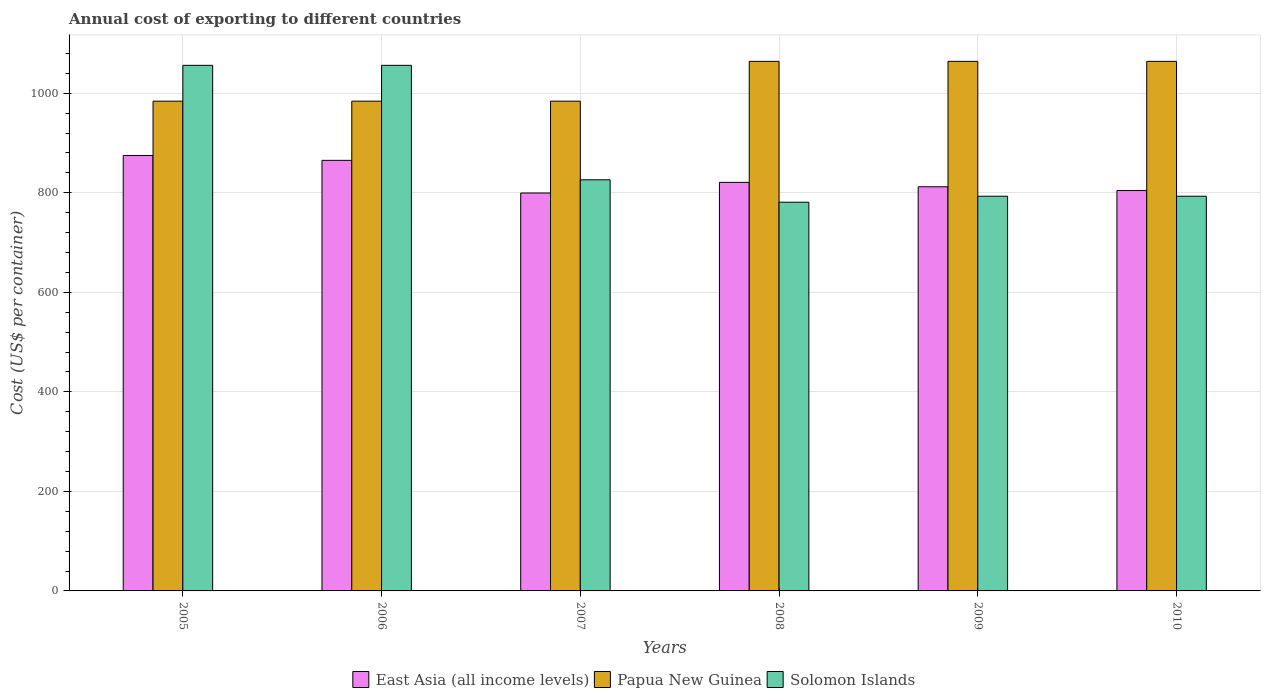How many different coloured bars are there?
Your response must be concise. 3. How many groups of bars are there?
Give a very brief answer. 6. Are the number of bars on each tick of the X-axis equal?
Your response must be concise. Yes. How many bars are there on the 2nd tick from the left?
Provide a short and direct response. 3. What is the total annual cost of exporting in Papua New Guinea in 2009?
Provide a succinct answer. 1064. Across all years, what is the maximum total annual cost of exporting in Papua New Guinea?
Offer a very short reply. 1064. Across all years, what is the minimum total annual cost of exporting in East Asia (all income levels)?
Keep it short and to the point. 799.5. In which year was the total annual cost of exporting in Solomon Islands minimum?
Ensure brevity in your answer.  2008. What is the total total annual cost of exporting in Solomon Islands in the graph?
Offer a very short reply. 5305. What is the difference between the total annual cost of exporting in East Asia (all income levels) in 2008 and the total annual cost of exporting in Solomon Islands in 2006?
Offer a very short reply. -235.14. What is the average total annual cost of exporting in East Asia (all income levels) per year?
Ensure brevity in your answer.  829.46. In the year 2009, what is the difference between the total annual cost of exporting in Papua New Guinea and total annual cost of exporting in East Asia (all income levels)?
Your answer should be compact. 252. In how many years, is the total annual cost of exporting in East Asia (all income levels) greater than 480 US$?
Your answer should be compact. 6. Is the total annual cost of exporting in Solomon Islands in 2005 less than that in 2007?
Make the answer very short. No. Is the difference between the total annual cost of exporting in Papua New Guinea in 2008 and 2010 greater than the difference between the total annual cost of exporting in East Asia (all income levels) in 2008 and 2010?
Offer a very short reply. No. What is the difference between the highest and the second highest total annual cost of exporting in East Asia (all income levels)?
Give a very brief answer. 9.78. What is the difference between the highest and the lowest total annual cost of exporting in East Asia (all income levels)?
Ensure brevity in your answer.  75.39. In how many years, is the total annual cost of exporting in Solomon Islands greater than the average total annual cost of exporting in Solomon Islands taken over all years?
Offer a very short reply. 2. Is the sum of the total annual cost of exporting in Solomon Islands in 2005 and 2010 greater than the maximum total annual cost of exporting in East Asia (all income levels) across all years?
Give a very brief answer. Yes. What does the 1st bar from the left in 2006 represents?
Your answer should be very brief. East Asia (all income levels). What does the 2nd bar from the right in 2010 represents?
Make the answer very short. Papua New Guinea. Is it the case that in every year, the sum of the total annual cost of exporting in Papua New Guinea and total annual cost of exporting in East Asia (all income levels) is greater than the total annual cost of exporting in Solomon Islands?
Keep it short and to the point. Yes. How many bars are there?
Your answer should be very brief. 18. What is the difference between two consecutive major ticks on the Y-axis?
Ensure brevity in your answer.  200. Are the values on the major ticks of Y-axis written in scientific E-notation?
Your response must be concise. No. Does the graph contain any zero values?
Your answer should be very brief. No. Does the graph contain grids?
Give a very brief answer. Yes. How are the legend labels stacked?
Provide a succinct answer. Horizontal. What is the title of the graph?
Your answer should be very brief. Annual cost of exporting to different countries. Does "Croatia" appear as one of the legend labels in the graph?
Give a very brief answer. No. What is the label or title of the Y-axis?
Your answer should be compact. Cost (US$ per container). What is the Cost (US$ per container) in East Asia (all income levels) in 2005?
Keep it short and to the point. 874.89. What is the Cost (US$ per container) in Papua New Guinea in 2005?
Ensure brevity in your answer.  984. What is the Cost (US$ per container) of Solomon Islands in 2005?
Your answer should be compact. 1056. What is the Cost (US$ per container) in East Asia (all income levels) in 2006?
Your answer should be compact. 865.11. What is the Cost (US$ per container) of Papua New Guinea in 2006?
Keep it short and to the point. 984. What is the Cost (US$ per container) in Solomon Islands in 2006?
Make the answer very short. 1056. What is the Cost (US$ per container) of East Asia (all income levels) in 2007?
Make the answer very short. 799.5. What is the Cost (US$ per container) of Papua New Guinea in 2007?
Make the answer very short. 984. What is the Cost (US$ per container) in Solomon Islands in 2007?
Offer a very short reply. 826. What is the Cost (US$ per container) in East Asia (all income levels) in 2008?
Provide a succinct answer. 820.86. What is the Cost (US$ per container) in Papua New Guinea in 2008?
Keep it short and to the point. 1064. What is the Cost (US$ per container) in Solomon Islands in 2008?
Your answer should be very brief. 781. What is the Cost (US$ per container) of East Asia (all income levels) in 2009?
Keep it short and to the point. 812. What is the Cost (US$ per container) of Papua New Guinea in 2009?
Ensure brevity in your answer.  1064. What is the Cost (US$ per container) in Solomon Islands in 2009?
Make the answer very short. 793. What is the Cost (US$ per container) of East Asia (all income levels) in 2010?
Keep it short and to the point. 804.43. What is the Cost (US$ per container) of Papua New Guinea in 2010?
Keep it short and to the point. 1064. What is the Cost (US$ per container) in Solomon Islands in 2010?
Ensure brevity in your answer.  793. Across all years, what is the maximum Cost (US$ per container) in East Asia (all income levels)?
Offer a very short reply. 874.89. Across all years, what is the maximum Cost (US$ per container) in Papua New Guinea?
Provide a short and direct response. 1064. Across all years, what is the maximum Cost (US$ per container) in Solomon Islands?
Keep it short and to the point. 1056. Across all years, what is the minimum Cost (US$ per container) of East Asia (all income levels)?
Ensure brevity in your answer.  799.5. Across all years, what is the minimum Cost (US$ per container) of Papua New Guinea?
Your answer should be compact. 984. Across all years, what is the minimum Cost (US$ per container) of Solomon Islands?
Your answer should be compact. 781. What is the total Cost (US$ per container) in East Asia (all income levels) in the graph?
Give a very brief answer. 4976.78. What is the total Cost (US$ per container) in Papua New Guinea in the graph?
Keep it short and to the point. 6144. What is the total Cost (US$ per container) in Solomon Islands in the graph?
Provide a succinct answer. 5305. What is the difference between the Cost (US$ per container) in East Asia (all income levels) in 2005 and that in 2006?
Provide a succinct answer. 9.78. What is the difference between the Cost (US$ per container) in Papua New Guinea in 2005 and that in 2006?
Your answer should be very brief. 0. What is the difference between the Cost (US$ per container) of East Asia (all income levels) in 2005 and that in 2007?
Provide a succinct answer. 75.39. What is the difference between the Cost (US$ per container) of Papua New Guinea in 2005 and that in 2007?
Keep it short and to the point. 0. What is the difference between the Cost (US$ per container) of Solomon Islands in 2005 and that in 2007?
Keep it short and to the point. 230. What is the difference between the Cost (US$ per container) of East Asia (all income levels) in 2005 and that in 2008?
Give a very brief answer. 54.03. What is the difference between the Cost (US$ per container) of Papua New Guinea in 2005 and that in 2008?
Offer a terse response. -80. What is the difference between the Cost (US$ per container) of Solomon Islands in 2005 and that in 2008?
Provide a succinct answer. 275. What is the difference between the Cost (US$ per container) in East Asia (all income levels) in 2005 and that in 2009?
Give a very brief answer. 62.89. What is the difference between the Cost (US$ per container) of Papua New Guinea in 2005 and that in 2009?
Keep it short and to the point. -80. What is the difference between the Cost (US$ per container) of Solomon Islands in 2005 and that in 2009?
Provide a succinct answer. 263. What is the difference between the Cost (US$ per container) in East Asia (all income levels) in 2005 and that in 2010?
Give a very brief answer. 70.46. What is the difference between the Cost (US$ per container) in Papua New Guinea in 2005 and that in 2010?
Offer a very short reply. -80. What is the difference between the Cost (US$ per container) of Solomon Islands in 2005 and that in 2010?
Your answer should be compact. 263. What is the difference between the Cost (US$ per container) in East Asia (all income levels) in 2006 and that in 2007?
Your answer should be compact. 65.61. What is the difference between the Cost (US$ per container) of Papua New Guinea in 2006 and that in 2007?
Offer a terse response. 0. What is the difference between the Cost (US$ per container) of Solomon Islands in 2006 and that in 2007?
Your answer should be very brief. 230. What is the difference between the Cost (US$ per container) of East Asia (all income levels) in 2006 and that in 2008?
Your answer should be very brief. 44.25. What is the difference between the Cost (US$ per container) in Papua New Guinea in 2006 and that in 2008?
Keep it short and to the point. -80. What is the difference between the Cost (US$ per container) in Solomon Islands in 2006 and that in 2008?
Your answer should be compact. 275. What is the difference between the Cost (US$ per container) in East Asia (all income levels) in 2006 and that in 2009?
Keep it short and to the point. 53.11. What is the difference between the Cost (US$ per container) in Papua New Guinea in 2006 and that in 2009?
Your answer should be very brief. -80. What is the difference between the Cost (US$ per container) in Solomon Islands in 2006 and that in 2009?
Ensure brevity in your answer.  263. What is the difference between the Cost (US$ per container) in East Asia (all income levels) in 2006 and that in 2010?
Offer a very short reply. 60.68. What is the difference between the Cost (US$ per container) of Papua New Guinea in 2006 and that in 2010?
Your answer should be compact. -80. What is the difference between the Cost (US$ per container) in Solomon Islands in 2006 and that in 2010?
Keep it short and to the point. 263. What is the difference between the Cost (US$ per container) of East Asia (all income levels) in 2007 and that in 2008?
Offer a very short reply. -21.36. What is the difference between the Cost (US$ per container) of Papua New Guinea in 2007 and that in 2008?
Your response must be concise. -80. What is the difference between the Cost (US$ per container) in Solomon Islands in 2007 and that in 2008?
Give a very brief answer. 45. What is the difference between the Cost (US$ per container) in East Asia (all income levels) in 2007 and that in 2009?
Offer a terse response. -12.5. What is the difference between the Cost (US$ per container) of Papua New Guinea in 2007 and that in 2009?
Provide a succinct answer. -80. What is the difference between the Cost (US$ per container) of East Asia (all income levels) in 2007 and that in 2010?
Make the answer very short. -4.93. What is the difference between the Cost (US$ per container) of Papua New Guinea in 2007 and that in 2010?
Offer a terse response. -80. What is the difference between the Cost (US$ per container) in East Asia (all income levels) in 2008 and that in 2009?
Your answer should be very brief. 8.86. What is the difference between the Cost (US$ per container) of Papua New Guinea in 2008 and that in 2009?
Provide a succinct answer. 0. What is the difference between the Cost (US$ per container) in East Asia (all income levels) in 2008 and that in 2010?
Offer a very short reply. 16.43. What is the difference between the Cost (US$ per container) in East Asia (all income levels) in 2009 and that in 2010?
Give a very brief answer. 7.57. What is the difference between the Cost (US$ per container) of Papua New Guinea in 2009 and that in 2010?
Provide a succinct answer. 0. What is the difference between the Cost (US$ per container) in Solomon Islands in 2009 and that in 2010?
Your answer should be compact. 0. What is the difference between the Cost (US$ per container) in East Asia (all income levels) in 2005 and the Cost (US$ per container) in Papua New Guinea in 2006?
Offer a terse response. -109.11. What is the difference between the Cost (US$ per container) of East Asia (all income levels) in 2005 and the Cost (US$ per container) of Solomon Islands in 2006?
Your answer should be very brief. -181.11. What is the difference between the Cost (US$ per container) of Papua New Guinea in 2005 and the Cost (US$ per container) of Solomon Islands in 2006?
Your response must be concise. -72. What is the difference between the Cost (US$ per container) of East Asia (all income levels) in 2005 and the Cost (US$ per container) of Papua New Guinea in 2007?
Keep it short and to the point. -109.11. What is the difference between the Cost (US$ per container) of East Asia (all income levels) in 2005 and the Cost (US$ per container) of Solomon Islands in 2007?
Your response must be concise. 48.89. What is the difference between the Cost (US$ per container) of Papua New Guinea in 2005 and the Cost (US$ per container) of Solomon Islands in 2007?
Your answer should be compact. 158. What is the difference between the Cost (US$ per container) in East Asia (all income levels) in 2005 and the Cost (US$ per container) in Papua New Guinea in 2008?
Your response must be concise. -189.11. What is the difference between the Cost (US$ per container) in East Asia (all income levels) in 2005 and the Cost (US$ per container) in Solomon Islands in 2008?
Make the answer very short. 93.89. What is the difference between the Cost (US$ per container) in Papua New Guinea in 2005 and the Cost (US$ per container) in Solomon Islands in 2008?
Your answer should be compact. 203. What is the difference between the Cost (US$ per container) of East Asia (all income levels) in 2005 and the Cost (US$ per container) of Papua New Guinea in 2009?
Give a very brief answer. -189.11. What is the difference between the Cost (US$ per container) in East Asia (all income levels) in 2005 and the Cost (US$ per container) in Solomon Islands in 2009?
Keep it short and to the point. 81.89. What is the difference between the Cost (US$ per container) of Papua New Guinea in 2005 and the Cost (US$ per container) of Solomon Islands in 2009?
Ensure brevity in your answer.  191. What is the difference between the Cost (US$ per container) in East Asia (all income levels) in 2005 and the Cost (US$ per container) in Papua New Guinea in 2010?
Provide a succinct answer. -189.11. What is the difference between the Cost (US$ per container) in East Asia (all income levels) in 2005 and the Cost (US$ per container) in Solomon Islands in 2010?
Offer a very short reply. 81.89. What is the difference between the Cost (US$ per container) in Papua New Guinea in 2005 and the Cost (US$ per container) in Solomon Islands in 2010?
Keep it short and to the point. 191. What is the difference between the Cost (US$ per container) in East Asia (all income levels) in 2006 and the Cost (US$ per container) in Papua New Guinea in 2007?
Your answer should be compact. -118.89. What is the difference between the Cost (US$ per container) in East Asia (all income levels) in 2006 and the Cost (US$ per container) in Solomon Islands in 2007?
Make the answer very short. 39.11. What is the difference between the Cost (US$ per container) in Papua New Guinea in 2006 and the Cost (US$ per container) in Solomon Islands in 2007?
Your answer should be compact. 158. What is the difference between the Cost (US$ per container) of East Asia (all income levels) in 2006 and the Cost (US$ per container) of Papua New Guinea in 2008?
Provide a short and direct response. -198.89. What is the difference between the Cost (US$ per container) of East Asia (all income levels) in 2006 and the Cost (US$ per container) of Solomon Islands in 2008?
Offer a very short reply. 84.11. What is the difference between the Cost (US$ per container) in Papua New Guinea in 2006 and the Cost (US$ per container) in Solomon Islands in 2008?
Provide a short and direct response. 203. What is the difference between the Cost (US$ per container) of East Asia (all income levels) in 2006 and the Cost (US$ per container) of Papua New Guinea in 2009?
Keep it short and to the point. -198.89. What is the difference between the Cost (US$ per container) of East Asia (all income levels) in 2006 and the Cost (US$ per container) of Solomon Islands in 2009?
Keep it short and to the point. 72.11. What is the difference between the Cost (US$ per container) in Papua New Guinea in 2006 and the Cost (US$ per container) in Solomon Islands in 2009?
Your answer should be compact. 191. What is the difference between the Cost (US$ per container) in East Asia (all income levels) in 2006 and the Cost (US$ per container) in Papua New Guinea in 2010?
Give a very brief answer. -198.89. What is the difference between the Cost (US$ per container) in East Asia (all income levels) in 2006 and the Cost (US$ per container) in Solomon Islands in 2010?
Keep it short and to the point. 72.11. What is the difference between the Cost (US$ per container) in Papua New Guinea in 2006 and the Cost (US$ per container) in Solomon Islands in 2010?
Your response must be concise. 191. What is the difference between the Cost (US$ per container) of East Asia (all income levels) in 2007 and the Cost (US$ per container) of Papua New Guinea in 2008?
Your answer should be compact. -264.5. What is the difference between the Cost (US$ per container) of East Asia (all income levels) in 2007 and the Cost (US$ per container) of Solomon Islands in 2008?
Provide a succinct answer. 18.5. What is the difference between the Cost (US$ per container) in Papua New Guinea in 2007 and the Cost (US$ per container) in Solomon Islands in 2008?
Ensure brevity in your answer.  203. What is the difference between the Cost (US$ per container) in East Asia (all income levels) in 2007 and the Cost (US$ per container) in Papua New Guinea in 2009?
Provide a succinct answer. -264.5. What is the difference between the Cost (US$ per container) in Papua New Guinea in 2007 and the Cost (US$ per container) in Solomon Islands in 2009?
Your answer should be compact. 191. What is the difference between the Cost (US$ per container) in East Asia (all income levels) in 2007 and the Cost (US$ per container) in Papua New Guinea in 2010?
Your response must be concise. -264.5. What is the difference between the Cost (US$ per container) of East Asia (all income levels) in 2007 and the Cost (US$ per container) of Solomon Islands in 2010?
Offer a very short reply. 6.5. What is the difference between the Cost (US$ per container) of Papua New Guinea in 2007 and the Cost (US$ per container) of Solomon Islands in 2010?
Give a very brief answer. 191. What is the difference between the Cost (US$ per container) of East Asia (all income levels) in 2008 and the Cost (US$ per container) of Papua New Guinea in 2009?
Keep it short and to the point. -243.14. What is the difference between the Cost (US$ per container) in East Asia (all income levels) in 2008 and the Cost (US$ per container) in Solomon Islands in 2009?
Provide a short and direct response. 27.86. What is the difference between the Cost (US$ per container) in Papua New Guinea in 2008 and the Cost (US$ per container) in Solomon Islands in 2009?
Keep it short and to the point. 271. What is the difference between the Cost (US$ per container) in East Asia (all income levels) in 2008 and the Cost (US$ per container) in Papua New Guinea in 2010?
Your response must be concise. -243.14. What is the difference between the Cost (US$ per container) in East Asia (all income levels) in 2008 and the Cost (US$ per container) in Solomon Islands in 2010?
Your answer should be very brief. 27.86. What is the difference between the Cost (US$ per container) in Papua New Guinea in 2008 and the Cost (US$ per container) in Solomon Islands in 2010?
Give a very brief answer. 271. What is the difference between the Cost (US$ per container) in East Asia (all income levels) in 2009 and the Cost (US$ per container) in Papua New Guinea in 2010?
Provide a short and direct response. -252. What is the difference between the Cost (US$ per container) in East Asia (all income levels) in 2009 and the Cost (US$ per container) in Solomon Islands in 2010?
Offer a terse response. 19. What is the difference between the Cost (US$ per container) in Papua New Guinea in 2009 and the Cost (US$ per container) in Solomon Islands in 2010?
Provide a short and direct response. 271. What is the average Cost (US$ per container) of East Asia (all income levels) per year?
Provide a short and direct response. 829.46. What is the average Cost (US$ per container) in Papua New Guinea per year?
Provide a succinct answer. 1024. What is the average Cost (US$ per container) of Solomon Islands per year?
Provide a short and direct response. 884.17. In the year 2005, what is the difference between the Cost (US$ per container) of East Asia (all income levels) and Cost (US$ per container) of Papua New Guinea?
Your response must be concise. -109.11. In the year 2005, what is the difference between the Cost (US$ per container) of East Asia (all income levels) and Cost (US$ per container) of Solomon Islands?
Your answer should be compact. -181.11. In the year 2005, what is the difference between the Cost (US$ per container) of Papua New Guinea and Cost (US$ per container) of Solomon Islands?
Offer a very short reply. -72. In the year 2006, what is the difference between the Cost (US$ per container) in East Asia (all income levels) and Cost (US$ per container) in Papua New Guinea?
Ensure brevity in your answer.  -118.89. In the year 2006, what is the difference between the Cost (US$ per container) of East Asia (all income levels) and Cost (US$ per container) of Solomon Islands?
Ensure brevity in your answer.  -190.89. In the year 2006, what is the difference between the Cost (US$ per container) of Papua New Guinea and Cost (US$ per container) of Solomon Islands?
Your answer should be very brief. -72. In the year 2007, what is the difference between the Cost (US$ per container) of East Asia (all income levels) and Cost (US$ per container) of Papua New Guinea?
Give a very brief answer. -184.5. In the year 2007, what is the difference between the Cost (US$ per container) in East Asia (all income levels) and Cost (US$ per container) in Solomon Islands?
Your answer should be very brief. -26.5. In the year 2007, what is the difference between the Cost (US$ per container) in Papua New Guinea and Cost (US$ per container) in Solomon Islands?
Keep it short and to the point. 158. In the year 2008, what is the difference between the Cost (US$ per container) in East Asia (all income levels) and Cost (US$ per container) in Papua New Guinea?
Provide a short and direct response. -243.14. In the year 2008, what is the difference between the Cost (US$ per container) in East Asia (all income levels) and Cost (US$ per container) in Solomon Islands?
Your answer should be compact. 39.86. In the year 2008, what is the difference between the Cost (US$ per container) of Papua New Guinea and Cost (US$ per container) of Solomon Islands?
Provide a succinct answer. 283. In the year 2009, what is the difference between the Cost (US$ per container) of East Asia (all income levels) and Cost (US$ per container) of Papua New Guinea?
Make the answer very short. -252. In the year 2009, what is the difference between the Cost (US$ per container) of Papua New Guinea and Cost (US$ per container) of Solomon Islands?
Your answer should be very brief. 271. In the year 2010, what is the difference between the Cost (US$ per container) of East Asia (all income levels) and Cost (US$ per container) of Papua New Guinea?
Offer a very short reply. -259.57. In the year 2010, what is the difference between the Cost (US$ per container) in East Asia (all income levels) and Cost (US$ per container) in Solomon Islands?
Your answer should be compact. 11.43. In the year 2010, what is the difference between the Cost (US$ per container) of Papua New Guinea and Cost (US$ per container) of Solomon Islands?
Offer a terse response. 271. What is the ratio of the Cost (US$ per container) of East Asia (all income levels) in 2005 to that in 2006?
Offer a very short reply. 1.01. What is the ratio of the Cost (US$ per container) of Papua New Guinea in 2005 to that in 2006?
Your response must be concise. 1. What is the ratio of the Cost (US$ per container) in East Asia (all income levels) in 2005 to that in 2007?
Offer a terse response. 1.09. What is the ratio of the Cost (US$ per container) in Solomon Islands in 2005 to that in 2007?
Make the answer very short. 1.28. What is the ratio of the Cost (US$ per container) in East Asia (all income levels) in 2005 to that in 2008?
Your answer should be very brief. 1.07. What is the ratio of the Cost (US$ per container) of Papua New Guinea in 2005 to that in 2008?
Offer a very short reply. 0.92. What is the ratio of the Cost (US$ per container) of Solomon Islands in 2005 to that in 2008?
Offer a terse response. 1.35. What is the ratio of the Cost (US$ per container) of East Asia (all income levels) in 2005 to that in 2009?
Your response must be concise. 1.08. What is the ratio of the Cost (US$ per container) of Papua New Guinea in 2005 to that in 2009?
Ensure brevity in your answer.  0.92. What is the ratio of the Cost (US$ per container) in Solomon Islands in 2005 to that in 2009?
Keep it short and to the point. 1.33. What is the ratio of the Cost (US$ per container) in East Asia (all income levels) in 2005 to that in 2010?
Offer a very short reply. 1.09. What is the ratio of the Cost (US$ per container) in Papua New Guinea in 2005 to that in 2010?
Give a very brief answer. 0.92. What is the ratio of the Cost (US$ per container) in Solomon Islands in 2005 to that in 2010?
Provide a short and direct response. 1.33. What is the ratio of the Cost (US$ per container) in East Asia (all income levels) in 2006 to that in 2007?
Your response must be concise. 1.08. What is the ratio of the Cost (US$ per container) in Papua New Guinea in 2006 to that in 2007?
Provide a short and direct response. 1. What is the ratio of the Cost (US$ per container) in Solomon Islands in 2006 to that in 2007?
Your answer should be very brief. 1.28. What is the ratio of the Cost (US$ per container) of East Asia (all income levels) in 2006 to that in 2008?
Provide a succinct answer. 1.05. What is the ratio of the Cost (US$ per container) of Papua New Guinea in 2006 to that in 2008?
Provide a succinct answer. 0.92. What is the ratio of the Cost (US$ per container) in Solomon Islands in 2006 to that in 2008?
Your answer should be very brief. 1.35. What is the ratio of the Cost (US$ per container) in East Asia (all income levels) in 2006 to that in 2009?
Provide a short and direct response. 1.07. What is the ratio of the Cost (US$ per container) of Papua New Guinea in 2006 to that in 2009?
Offer a terse response. 0.92. What is the ratio of the Cost (US$ per container) in Solomon Islands in 2006 to that in 2009?
Provide a succinct answer. 1.33. What is the ratio of the Cost (US$ per container) of East Asia (all income levels) in 2006 to that in 2010?
Give a very brief answer. 1.08. What is the ratio of the Cost (US$ per container) of Papua New Guinea in 2006 to that in 2010?
Your answer should be compact. 0.92. What is the ratio of the Cost (US$ per container) in Solomon Islands in 2006 to that in 2010?
Ensure brevity in your answer.  1.33. What is the ratio of the Cost (US$ per container) in Papua New Guinea in 2007 to that in 2008?
Offer a terse response. 0.92. What is the ratio of the Cost (US$ per container) of Solomon Islands in 2007 to that in 2008?
Keep it short and to the point. 1.06. What is the ratio of the Cost (US$ per container) in East Asia (all income levels) in 2007 to that in 2009?
Provide a short and direct response. 0.98. What is the ratio of the Cost (US$ per container) in Papua New Guinea in 2007 to that in 2009?
Your response must be concise. 0.92. What is the ratio of the Cost (US$ per container) of Solomon Islands in 2007 to that in 2009?
Your answer should be compact. 1.04. What is the ratio of the Cost (US$ per container) of Papua New Guinea in 2007 to that in 2010?
Offer a very short reply. 0.92. What is the ratio of the Cost (US$ per container) of Solomon Islands in 2007 to that in 2010?
Offer a very short reply. 1.04. What is the ratio of the Cost (US$ per container) in East Asia (all income levels) in 2008 to that in 2009?
Ensure brevity in your answer.  1.01. What is the ratio of the Cost (US$ per container) in Papua New Guinea in 2008 to that in 2009?
Your answer should be very brief. 1. What is the ratio of the Cost (US$ per container) in Solomon Islands in 2008 to that in 2009?
Offer a terse response. 0.98. What is the ratio of the Cost (US$ per container) in East Asia (all income levels) in 2008 to that in 2010?
Give a very brief answer. 1.02. What is the ratio of the Cost (US$ per container) in Solomon Islands in 2008 to that in 2010?
Keep it short and to the point. 0.98. What is the ratio of the Cost (US$ per container) in East Asia (all income levels) in 2009 to that in 2010?
Your response must be concise. 1.01. What is the difference between the highest and the second highest Cost (US$ per container) in East Asia (all income levels)?
Your answer should be compact. 9.78. What is the difference between the highest and the second highest Cost (US$ per container) of Papua New Guinea?
Your response must be concise. 0. What is the difference between the highest and the second highest Cost (US$ per container) in Solomon Islands?
Your answer should be very brief. 0. What is the difference between the highest and the lowest Cost (US$ per container) of East Asia (all income levels)?
Your response must be concise. 75.39. What is the difference between the highest and the lowest Cost (US$ per container) in Papua New Guinea?
Provide a short and direct response. 80. What is the difference between the highest and the lowest Cost (US$ per container) of Solomon Islands?
Keep it short and to the point. 275. 